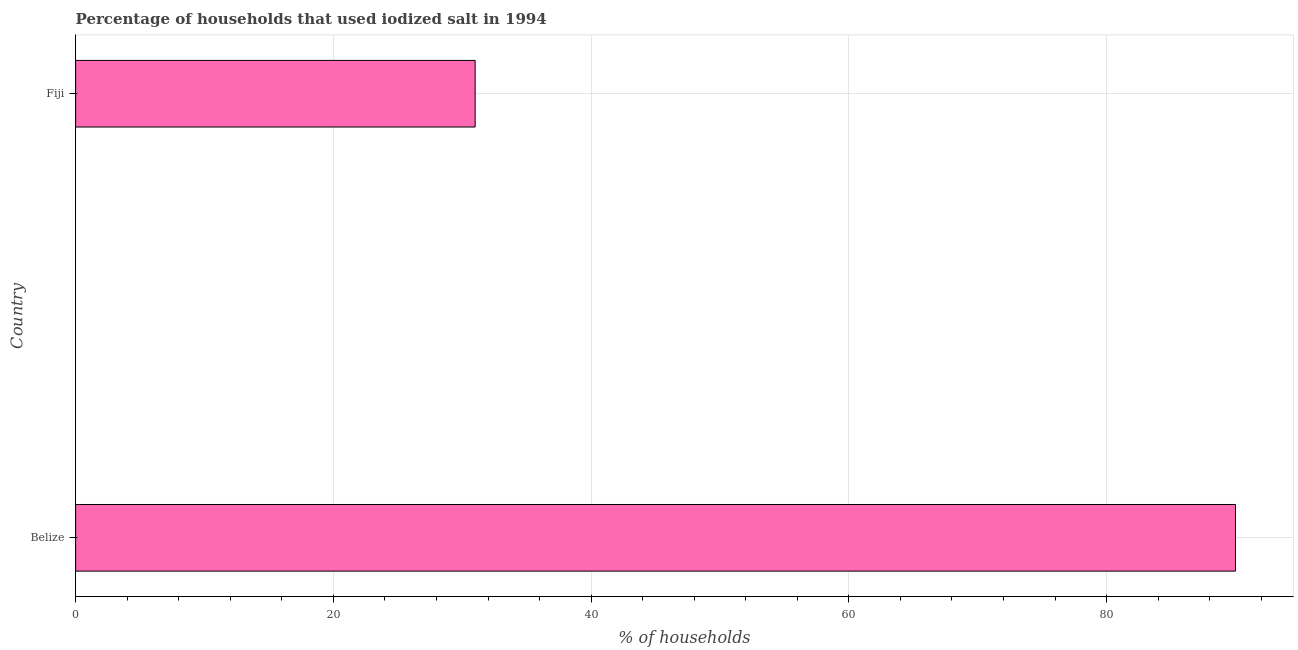Does the graph contain any zero values?
Provide a succinct answer. No. What is the title of the graph?
Ensure brevity in your answer.  Percentage of households that used iodized salt in 1994. What is the label or title of the X-axis?
Make the answer very short. % of households. What is the label or title of the Y-axis?
Your response must be concise. Country. What is the percentage of households where iodized salt is consumed in Belize?
Provide a succinct answer. 90. In which country was the percentage of households where iodized salt is consumed maximum?
Your answer should be very brief. Belize. In which country was the percentage of households where iodized salt is consumed minimum?
Your response must be concise. Fiji. What is the sum of the percentage of households where iodized salt is consumed?
Your response must be concise. 121. What is the difference between the percentage of households where iodized salt is consumed in Belize and Fiji?
Your response must be concise. 59. What is the average percentage of households where iodized salt is consumed per country?
Offer a very short reply. 60. What is the median percentage of households where iodized salt is consumed?
Your answer should be compact. 60.5. In how many countries, is the percentage of households where iodized salt is consumed greater than 60 %?
Make the answer very short. 1. What is the ratio of the percentage of households where iodized salt is consumed in Belize to that in Fiji?
Give a very brief answer. 2.9. Is the percentage of households where iodized salt is consumed in Belize less than that in Fiji?
Ensure brevity in your answer.  No. How many bars are there?
Keep it short and to the point. 2. How many countries are there in the graph?
Ensure brevity in your answer.  2. What is the % of households of Fiji?
Your answer should be very brief. 31. What is the difference between the % of households in Belize and Fiji?
Ensure brevity in your answer.  59. What is the ratio of the % of households in Belize to that in Fiji?
Ensure brevity in your answer.  2.9. 